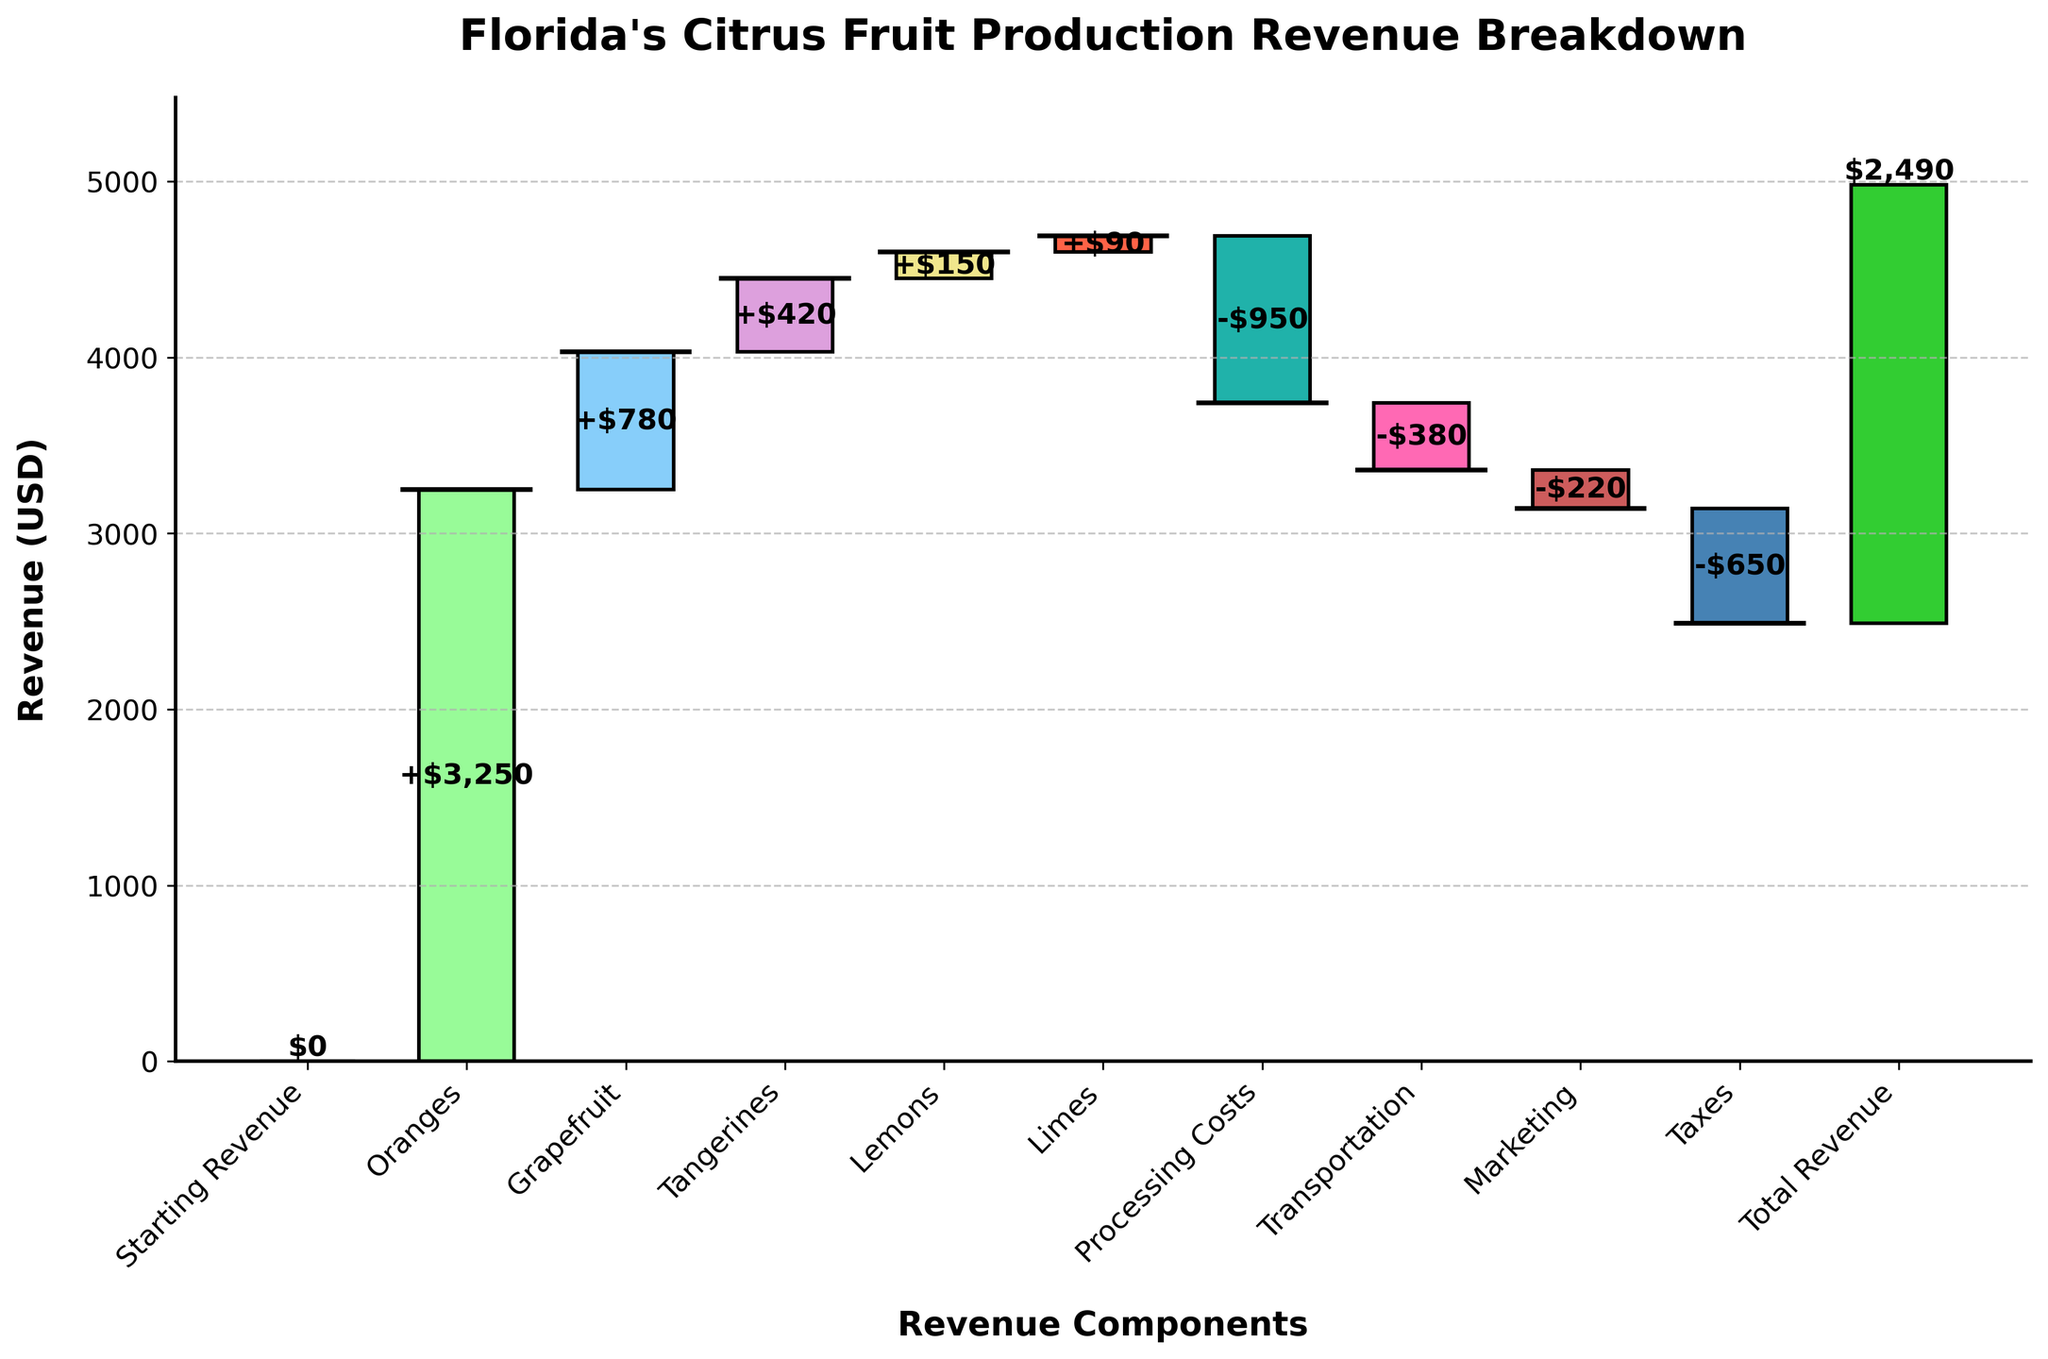What's the total revenue from citrus fruit production? The total revenue is explicitly labeled at the end of the chart under 'Total Revenue'.
Answer: $2,490 Which citrus fruit generates the highest revenue? By comparing the bars for each type of citrus fruit, the bar for oranges is the tallest, indicating the highest revenue.
Answer: Oranges How much revenue is contributed by grapefruits? The bar corresponding to grapefruits has a value of 780, which is explicitly labeled.
Answer: $780 What are the total costs listed in the waterfall chart? The costs include Processing Costs (-950), Transportation (-380), Marketing (-220), and Taxes (-650). Summing these: -950 + -380 + -220 + -650 = -2,200.
Answer: -$2,200 What is the difference in revenue between oranges and tangerines? The revenue from oranges is 3250, and from tangerines is 420. The difference is calculated as 3250 - 420 = 2830.
Answer: $2,830 Which cost category has the highest impact on the revenue? The longest bar among the costs categories is Processing Costs, with a value of -950.
Answer: Processing Costs What is the cumulative revenue after accounting for transportation costs? Starting from the cumulative revenue just before transportation, which includes revenue from all fruit sales and processing costs: 3250 + 780 + 420 + 150 + 90 - 950 = 3740. After accounting for transportation, it is 3740 - 380 = 3360.
Answer: $3,360 How much more revenue do limes generate compared to lemons? The revenue from limes is 90, and from lemons is 150. The comparison shows that lemons generate more revenue, not limes.
Answer: $60 less What is the approximate cumulative value after marketing costs are included? The cumulative value before marketing can be calculated as 3250 + 780 + 420 + 150 + 90 - 950 - 380 = 2980. After accounting for marketing costs: 2980 - 220 = 2760.
Answer: $2,760 